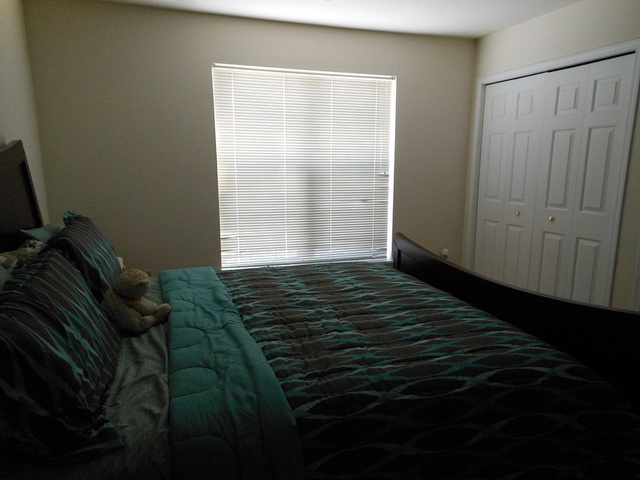Describe the objects in this image and their specific colors. I can see bed in tan, black, and teal tones and teddy bear in tan, black, darkgreen, and gray tones in this image. 